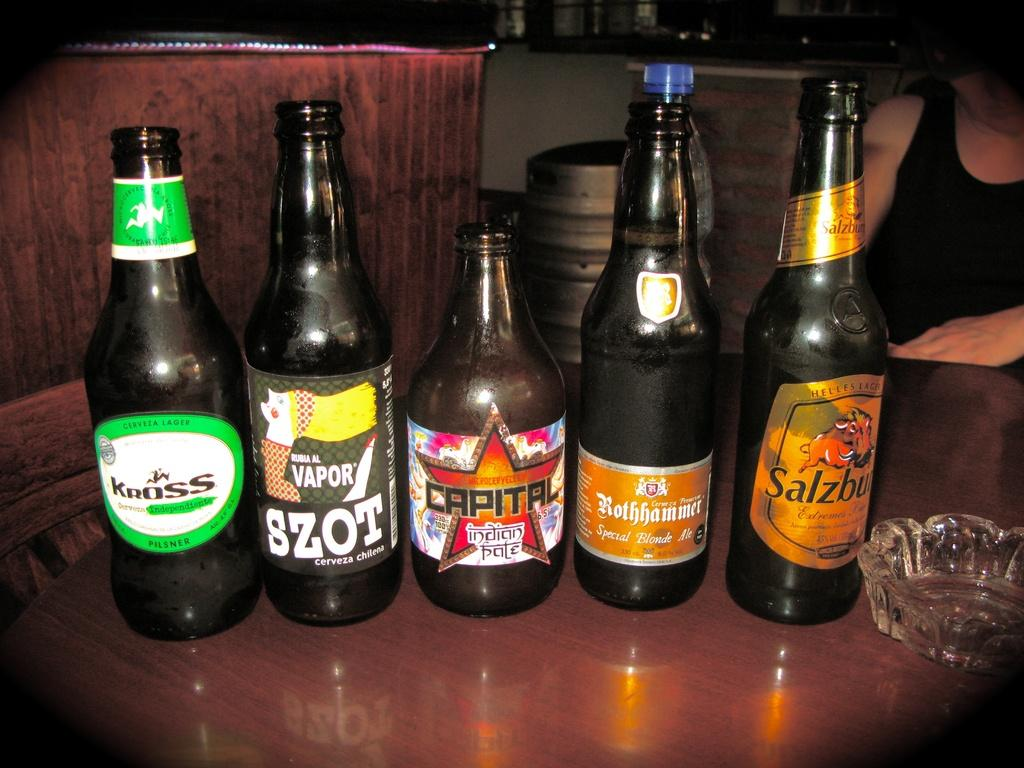<image>
Summarize the visual content of the image. Several beer bottles, including a Szot and Capital, are lined up in a row. 